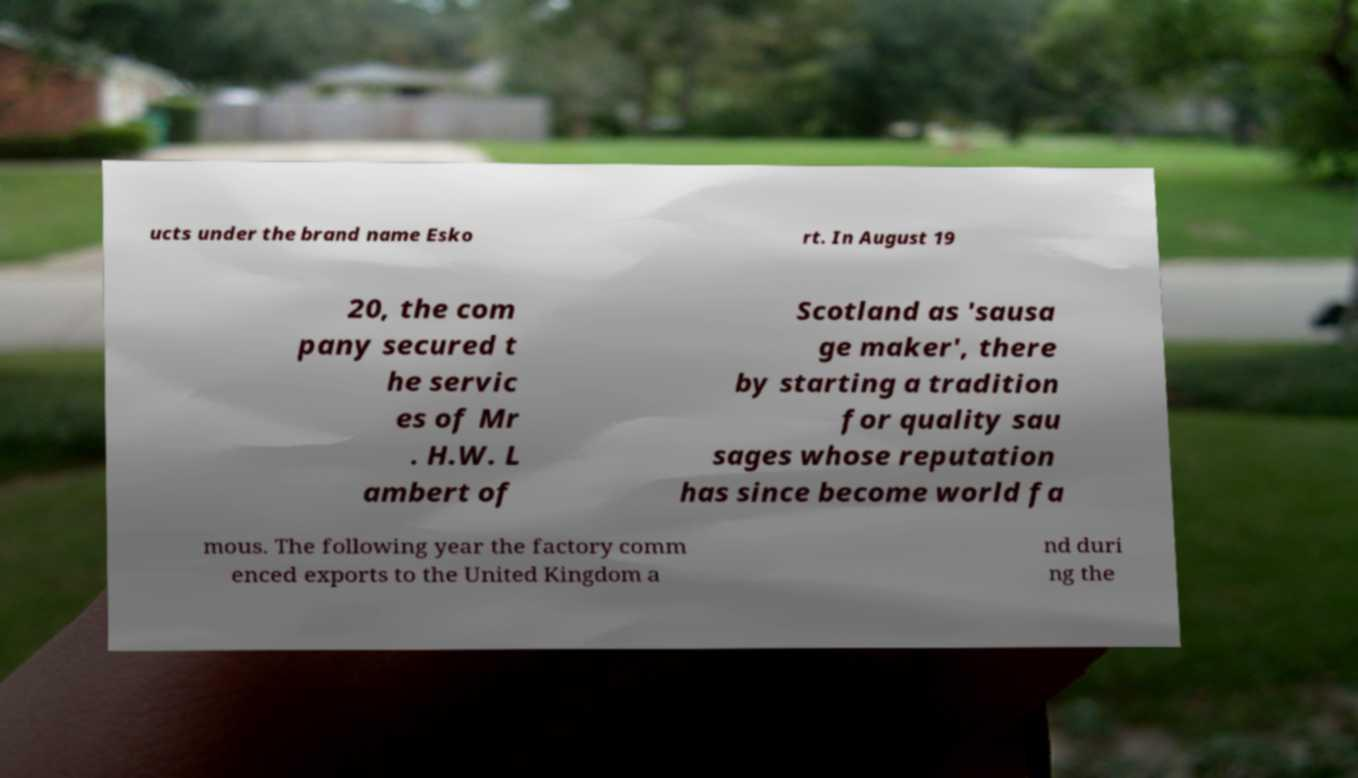Could you extract and type out the text from this image? ucts under the brand name Esko rt. In August 19 20, the com pany secured t he servic es of Mr . H.W. L ambert of Scotland as 'sausa ge maker', there by starting a tradition for quality sau sages whose reputation has since become world fa mous. The following year the factory comm enced exports to the United Kingdom a nd duri ng the 